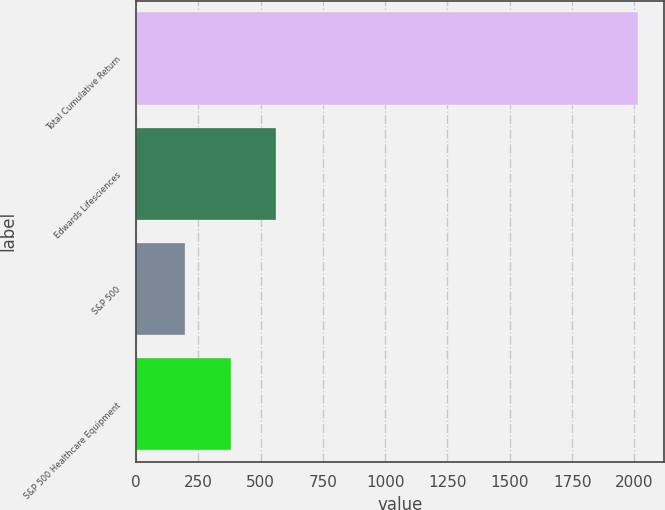Convert chart. <chart><loc_0><loc_0><loc_500><loc_500><bar_chart><fcel>Total Cumulative Return<fcel>Edwards Lifesciences<fcel>S&P 500<fcel>S&P 500 Healthcare Equipment<nl><fcel>2016<fcel>561.74<fcel>198.18<fcel>379.96<nl></chart> 